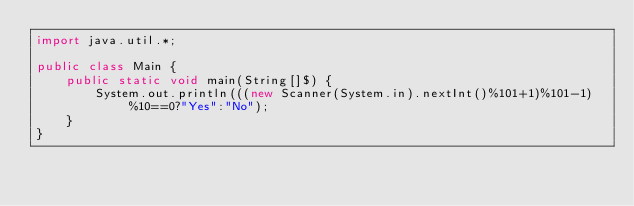Convert code to text. <code><loc_0><loc_0><loc_500><loc_500><_Java_>import java.util.*;

public class Main {
    public static void main(String[]$) {
        System.out.println(((new Scanner(System.in).nextInt()%101+1)%101-1)%10==0?"Yes":"No");
    }
}</code> 